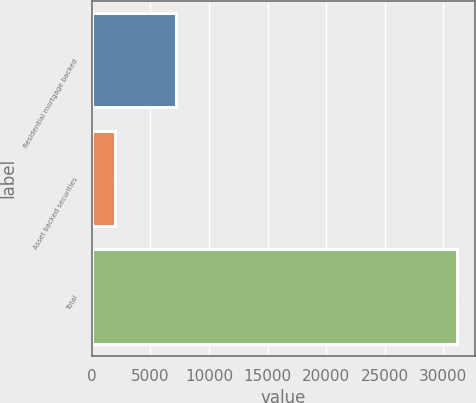Convert chart to OTSL. <chart><loc_0><loc_0><loc_500><loc_500><bar_chart><fcel>Residential mortgage backed<fcel>Asset backed securities<fcel>Total<nl><fcel>7213<fcel>1982<fcel>31133<nl></chart> 